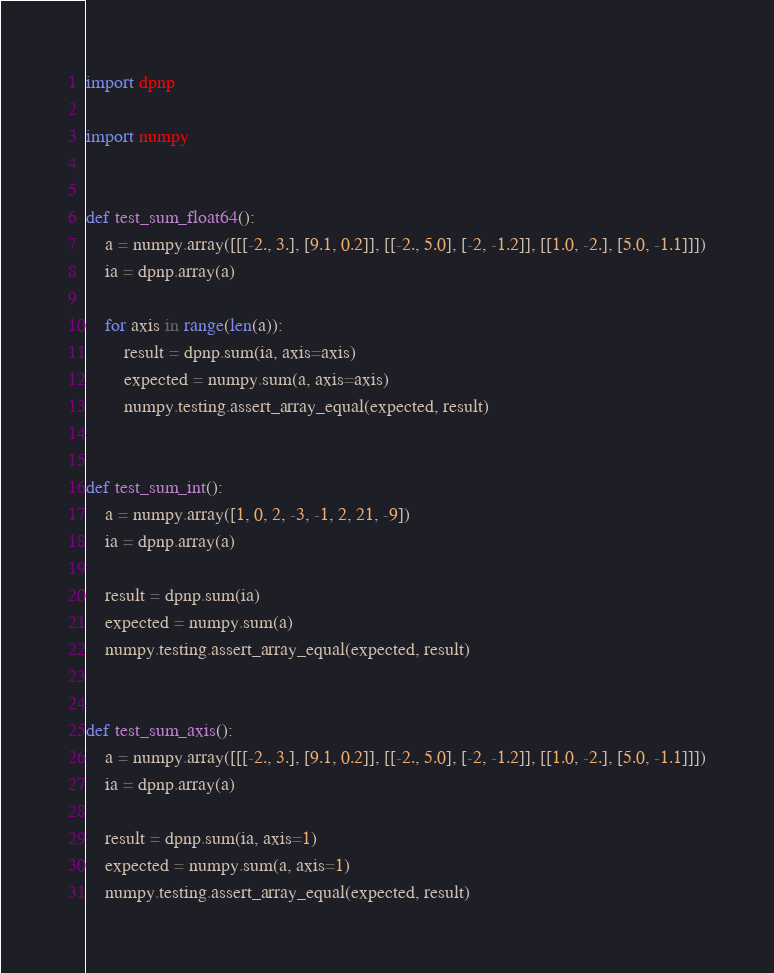<code> <loc_0><loc_0><loc_500><loc_500><_Python_>import dpnp

import numpy


def test_sum_float64():
    a = numpy.array([[[-2., 3.], [9.1, 0.2]], [[-2., 5.0], [-2, -1.2]], [[1.0, -2.], [5.0, -1.1]]])
    ia = dpnp.array(a)

    for axis in range(len(a)):
        result = dpnp.sum(ia, axis=axis)
        expected = numpy.sum(a, axis=axis)
        numpy.testing.assert_array_equal(expected, result)


def test_sum_int():
    a = numpy.array([1, 0, 2, -3, -1, 2, 21, -9])
    ia = dpnp.array(a)

    result = dpnp.sum(ia)
    expected = numpy.sum(a)
    numpy.testing.assert_array_equal(expected, result)


def test_sum_axis():
    a = numpy.array([[[-2., 3.], [9.1, 0.2]], [[-2., 5.0], [-2, -1.2]], [[1.0, -2.], [5.0, -1.1]]])
    ia = dpnp.array(a)

    result = dpnp.sum(ia, axis=1)
    expected = numpy.sum(a, axis=1)
    numpy.testing.assert_array_equal(expected, result)
</code> 